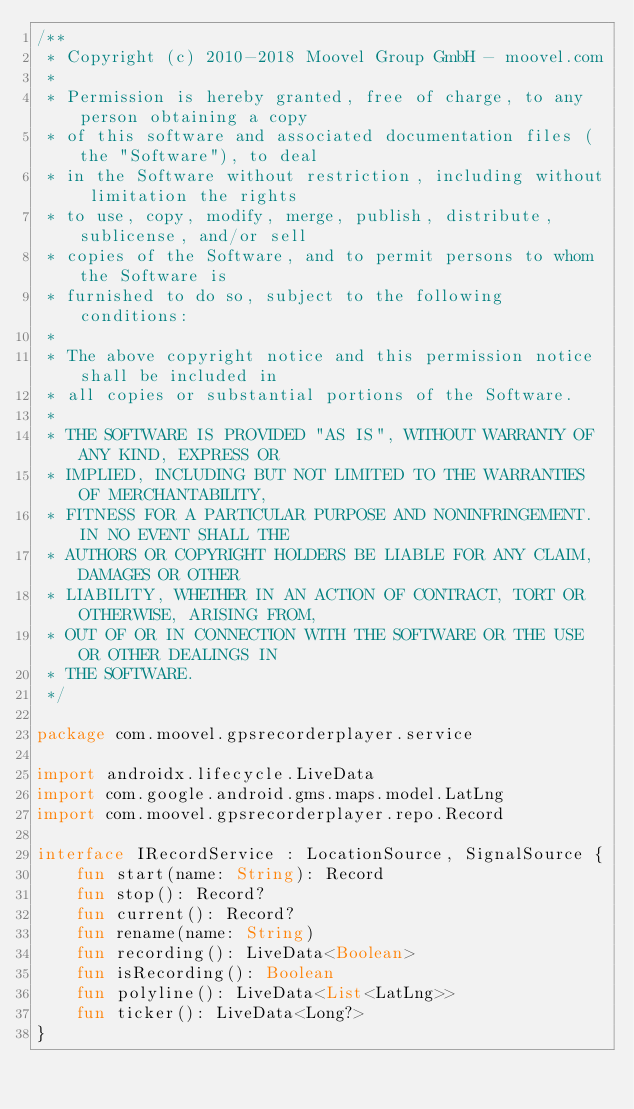<code> <loc_0><loc_0><loc_500><loc_500><_Kotlin_>/**
 * Copyright (c) 2010-2018 Moovel Group GmbH - moovel.com
 *
 * Permission is hereby granted, free of charge, to any person obtaining a copy
 * of this software and associated documentation files (the "Software"), to deal
 * in the Software without restriction, including without limitation the rights
 * to use, copy, modify, merge, publish, distribute, sublicense, and/or sell
 * copies of the Software, and to permit persons to whom the Software is
 * furnished to do so, subject to the following conditions:
 *
 * The above copyright notice and this permission notice shall be included in
 * all copies or substantial portions of the Software.
 *
 * THE SOFTWARE IS PROVIDED "AS IS", WITHOUT WARRANTY OF ANY KIND, EXPRESS OR
 * IMPLIED, INCLUDING BUT NOT LIMITED TO THE WARRANTIES OF MERCHANTABILITY,
 * FITNESS FOR A PARTICULAR PURPOSE AND NONINFRINGEMENT. IN NO EVENT SHALL THE
 * AUTHORS OR COPYRIGHT HOLDERS BE LIABLE FOR ANY CLAIM, DAMAGES OR OTHER
 * LIABILITY, WHETHER IN AN ACTION OF CONTRACT, TORT OR OTHERWISE, ARISING FROM,
 * OUT OF OR IN CONNECTION WITH THE SOFTWARE OR THE USE OR OTHER DEALINGS IN
 * THE SOFTWARE.
 */

package com.moovel.gpsrecorderplayer.service

import androidx.lifecycle.LiveData
import com.google.android.gms.maps.model.LatLng
import com.moovel.gpsrecorderplayer.repo.Record

interface IRecordService : LocationSource, SignalSource {
    fun start(name: String): Record
    fun stop(): Record?
    fun current(): Record?
    fun rename(name: String)
    fun recording(): LiveData<Boolean>
    fun isRecording(): Boolean
    fun polyline(): LiveData<List<LatLng>>
    fun ticker(): LiveData<Long?>
}
</code> 